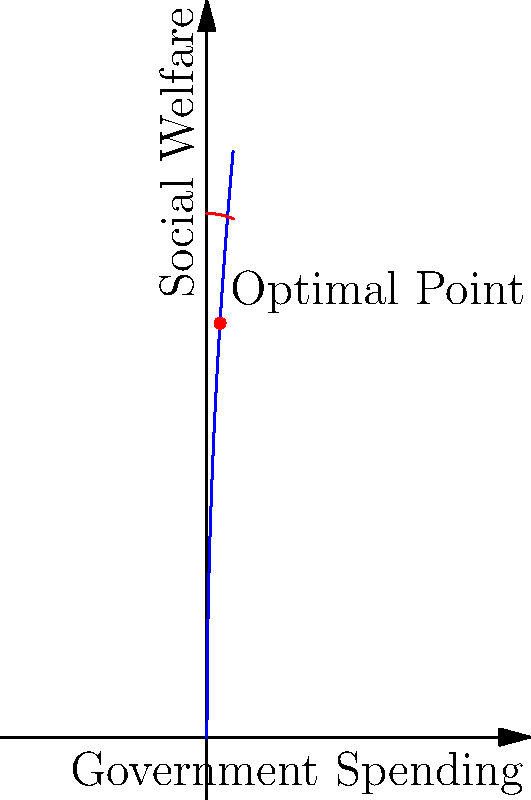As a campaign manager, you're tasked with optimizing social welfare given budget constraints. The social welfare function is given by $W(x) = 100\sqrt{x}$, where $x$ is government spending in billions of dollars. The budget constraint is represented by $B(x) = 400 - \frac{x^2}{100}$. Find the optimal level of government spending that maximizes social welfare while satisfying the budget constraint. To find the optimal point, we need to follow these steps:

1) The optimal point occurs where the social welfare function intersects the budget constraint. At this point, $W(x) = B(x)$.

2) Set up the equation:
   $100\sqrt{x} = 400 - \frac{x^2}{100}$

3) Square both sides:
   $10000x = 160000 - 800x + \frac{x^4}{10000}$

4) Rearrange:
   $\frac{x^4}{10000} + 10800x - 160000 = 0$

5) This is a 4th degree polynomial equation. It's difficult to solve analytically, but we can solve it numerically or graphically.

6) The solution is approximately $x = 10$ billion dollars.

7) We can verify this by plugging it back into both equations:
   $W(10) = 100\sqrt{10} \approx 316.23$
   $B(10) = 400 - \frac{10^2}{100} = 400 - 1 = 399$

8) This shows that at $x = 10$, the social welfare function value is slightly below the budget constraint, which is the optimal point.

Therefore, the optimal government spending is approximately 10 billion dollars, which maximizes social welfare while staying within the budget constraint.
Answer: $10 billion 